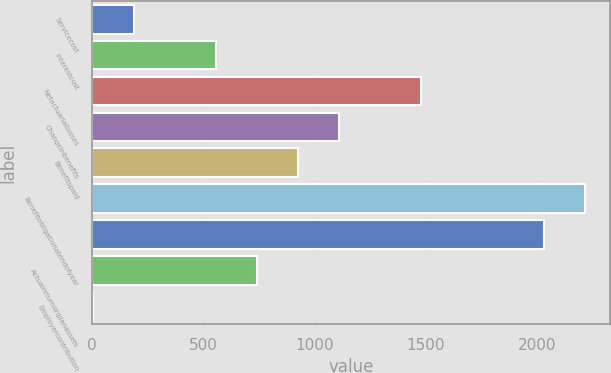Convert chart to OTSL. <chart><loc_0><loc_0><loc_500><loc_500><bar_chart><fcel>Servicecost<fcel>Interestcost<fcel>Netactuariallosses<fcel>Changeinbenefits<fcel>Benefitspaid<fcel>Benefitobligationatendofyear<fcel>Unnamed: 6<fcel>Actualreturnonplanassets<fcel>Employercontribution<nl><fcel>188.3<fcel>556.9<fcel>1478.4<fcel>1109.8<fcel>925.5<fcel>2215.6<fcel>2031.3<fcel>741.2<fcel>4<nl></chart> 